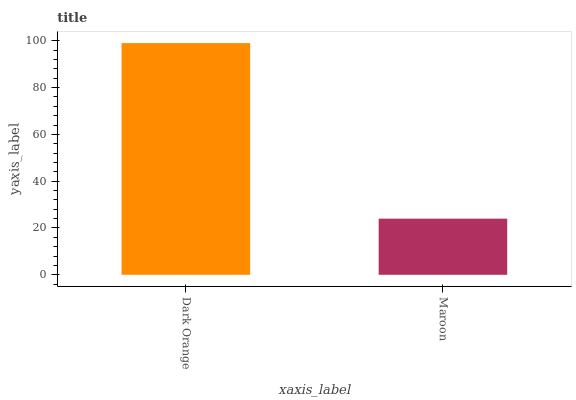Is Maroon the minimum?
Answer yes or no. Yes. Is Dark Orange the maximum?
Answer yes or no. Yes. Is Maroon the maximum?
Answer yes or no. No. Is Dark Orange greater than Maroon?
Answer yes or no. Yes. Is Maroon less than Dark Orange?
Answer yes or no. Yes. Is Maroon greater than Dark Orange?
Answer yes or no. No. Is Dark Orange less than Maroon?
Answer yes or no. No. Is Dark Orange the high median?
Answer yes or no. Yes. Is Maroon the low median?
Answer yes or no. Yes. Is Maroon the high median?
Answer yes or no. No. Is Dark Orange the low median?
Answer yes or no. No. 